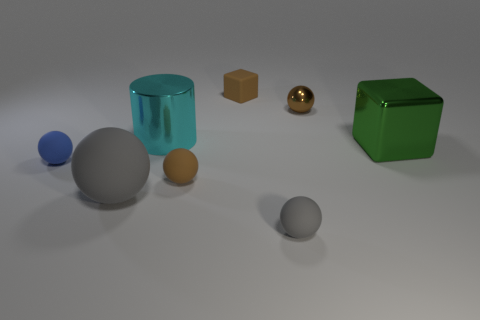Are there any other things that are the same shape as the large cyan thing?
Give a very brief answer. No. What is the material of the large cyan cylinder on the right side of the matte object that is left of the big matte ball?
Offer a very short reply. Metal. Does the tiny object to the right of the tiny gray matte sphere have the same color as the cylinder?
Make the answer very short. No. Is there anything else that has the same material as the tiny brown cube?
Keep it short and to the point. Yes. How many other objects have the same shape as the brown metal thing?
Ensure brevity in your answer.  4. What size is the blue object that is made of the same material as the small block?
Your answer should be very brief. Small. Are there any big green shiny blocks that are to the left of the metallic thing that is on the left side of the sphere that is behind the green block?
Ensure brevity in your answer.  No. Does the gray ball that is to the right of the cylinder have the same size as the big gray rubber object?
Provide a succinct answer. No. How many brown matte blocks have the same size as the blue ball?
Provide a short and direct response. 1. The other sphere that is the same color as the tiny shiny sphere is what size?
Keep it short and to the point. Small. 